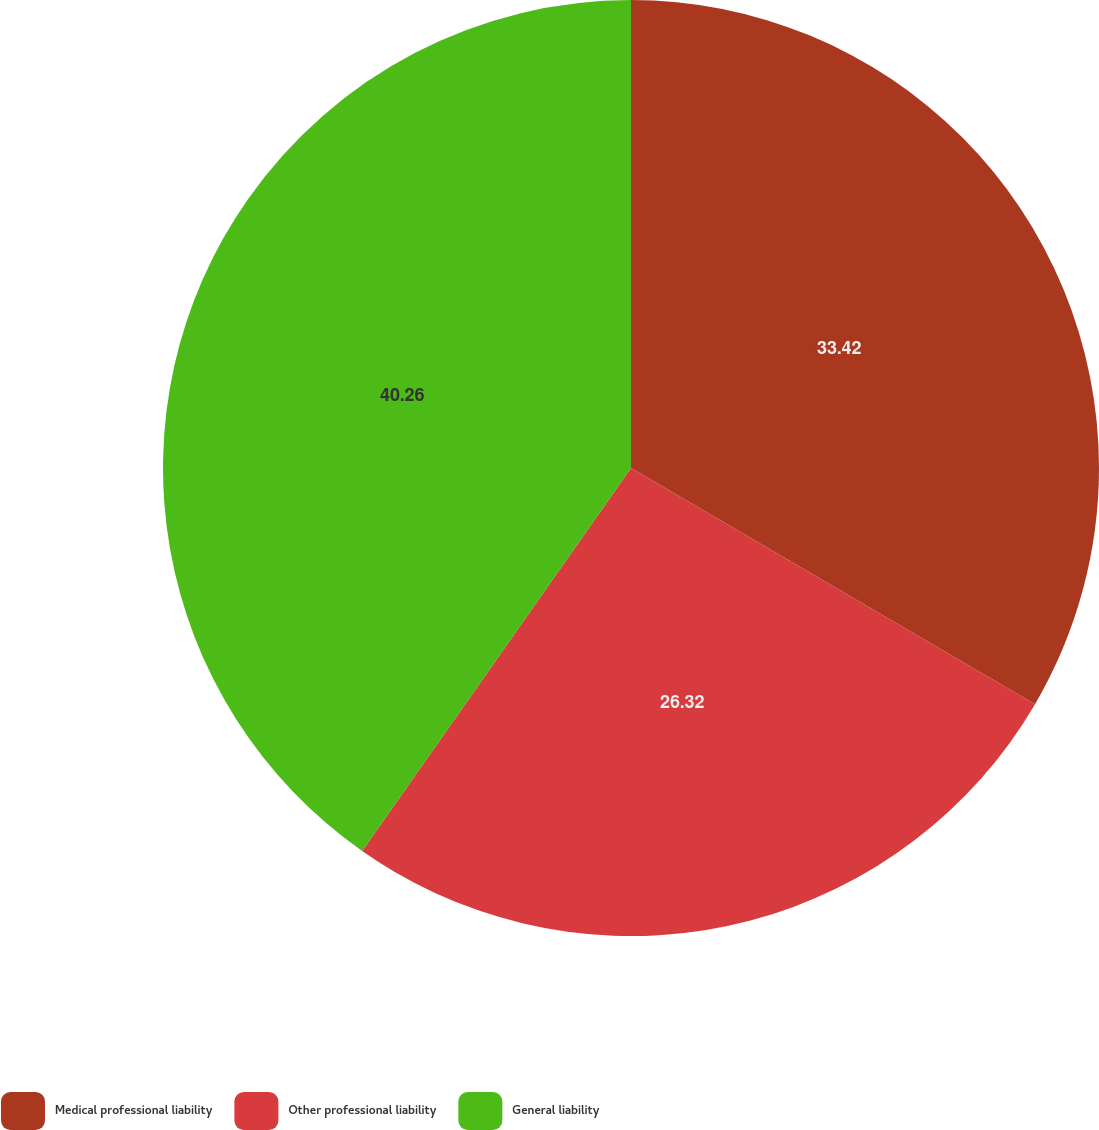Convert chart. <chart><loc_0><loc_0><loc_500><loc_500><pie_chart><fcel>Medical professional liability<fcel>Other professional liability<fcel>General liability<nl><fcel>33.42%<fcel>26.32%<fcel>40.26%<nl></chart> 